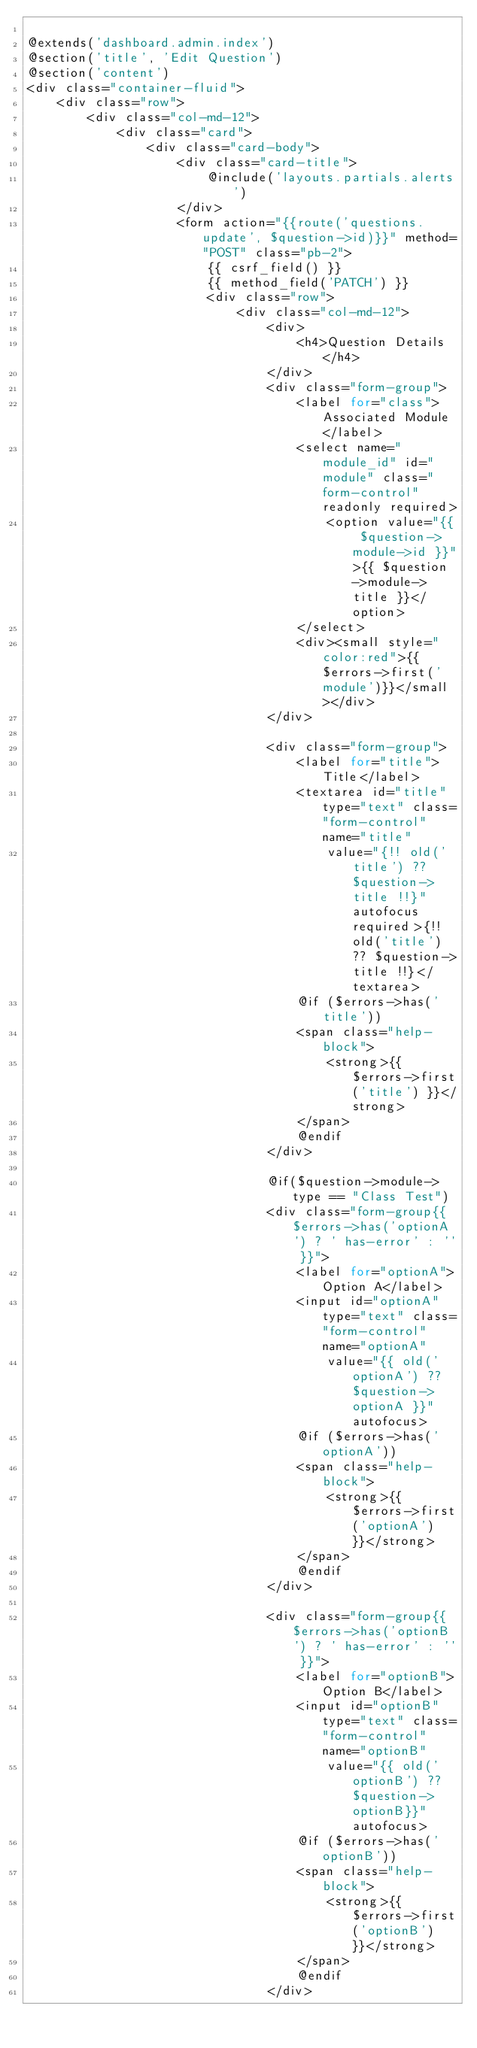<code> <loc_0><loc_0><loc_500><loc_500><_PHP_>
@extends('dashboard.admin.index')
@section('title', 'Edit Question')
@section('content')
<div class="container-fluid">
    <div class="row">
        <div class="col-md-12">
            <div class="card">
                <div class="card-body">
                    <div class="card-title">
                        @include('layouts.partials.alerts')
                    </div>
                    <form action="{{route('questions.update', $question->id)}}" method="POST" class="pb-2">
                        {{ csrf_field() }}
                        {{ method_field('PATCH') }}
                        <div class="row">
                            <div class="col-md-12">
                                <div>
                                    <h4>Question Details</h4>
                                </div>
                                <div class="form-group">
                                    <label for="class">Associated Module</label>
                                    <select name="module_id" id="module" class="form-control" readonly required>
                                        <option value="{{ $question->module->id }}">{{ $question->module->title }}</option>
                                    </select>
                                    <div><small style="color:red">{{ $errors->first('module')}}</small></div>
                                </div>

                                <div class="form-group">
                                    <label for="title">Title</label>
                                    <textarea id="title" type="text" class="form-control" name="title"
                                        value="{!! old('title') ?? $question->title !!}" autofocus required>{!! old('title') ?? $question->title !!}</textarea>
                                    @if ($errors->has('title'))
                                    <span class="help-block">
                                        <strong>{{ $errors->first('title') }}</strong>
                                    </span>
                                    @endif
                                </div>
                                
                                @if($question->module->type == "Class Test")
                                <div class="form-group{{ $errors->has('optionA') ? ' has-error' : '' }}">
                                    <label for="optionA">Option A</label>
                                    <input id="optionA" type="text" class="form-control" name="optionA"
                                        value="{{ old('optionA') ?? $question->optionA }}" autofocus>
                                    @if ($errors->has('optionA'))
                                    <span class="help-block">
                                        <strong>{{ $errors->first('optionA') }}</strong>
                                    </span>
                                    @endif
                                </div>

                                <div class="form-group{{ $errors->has('optionB') ? ' has-error' : '' }}">
                                    <label for="optionB">Option B</label>
                                    <input id="optionB" type="text" class="form-control" name="optionB"
                                        value="{{ old('optionB') ?? $question->optionB}}" autofocus>
                                    @if ($errors->has('optionB'))
                                    <span class="help-block">
                                        <strong>{{ $errors->first('optionB') }}</strong>
                                    </span>
                                    @endif
                                </div>
</code> 